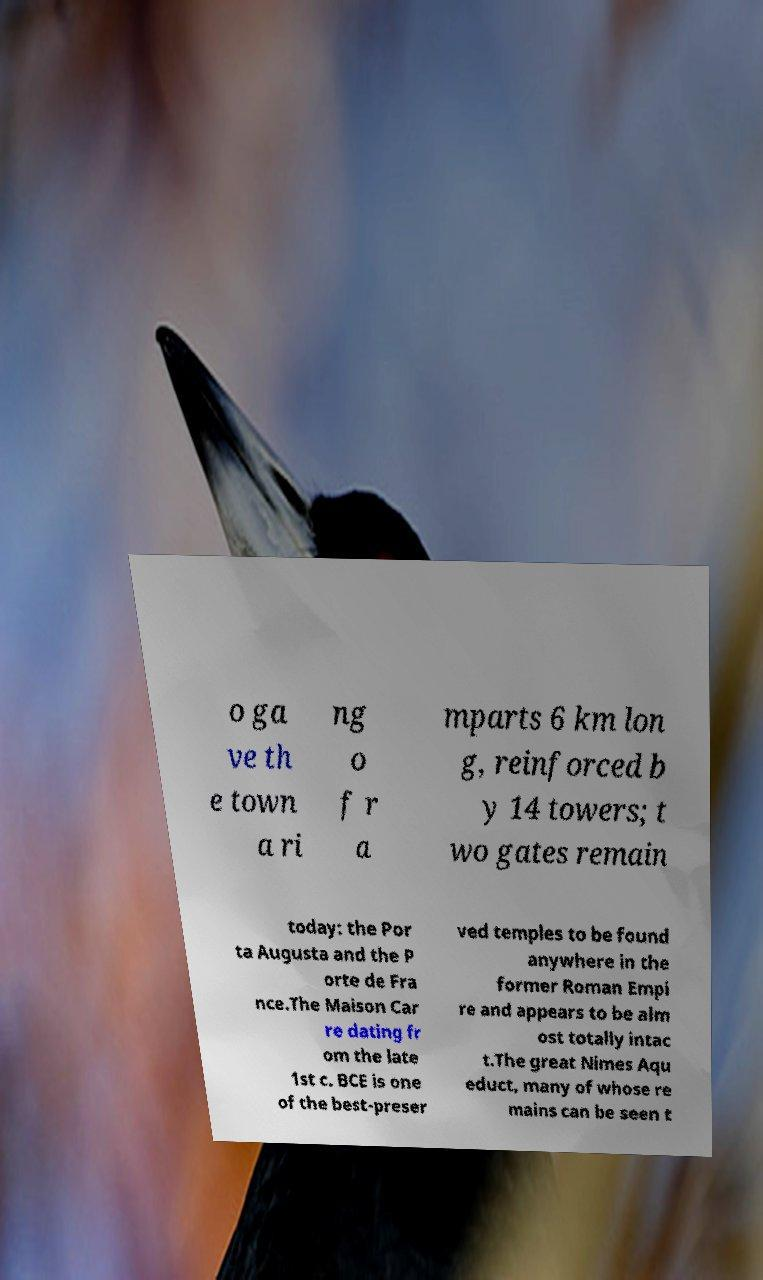Can you read and provide the text displayed in the image?This photo seems to have some interesting text. Can you extract and type it out for me? o ga ve th e town a ri ng o f r a mparts 6 km lon g, reinforced b y 14 towers; t wo gates remain today: the Por ta Augusta and the P orte de Fra nce.The Maison Car re dating fr om the late 1st c. BCE is one of the best-preser ved temples to be found anywhere in the former Roman Empi re and appears to be alm ost totally intac t.The great Nimes Aqu educt, many of whose re mains can be seen t 